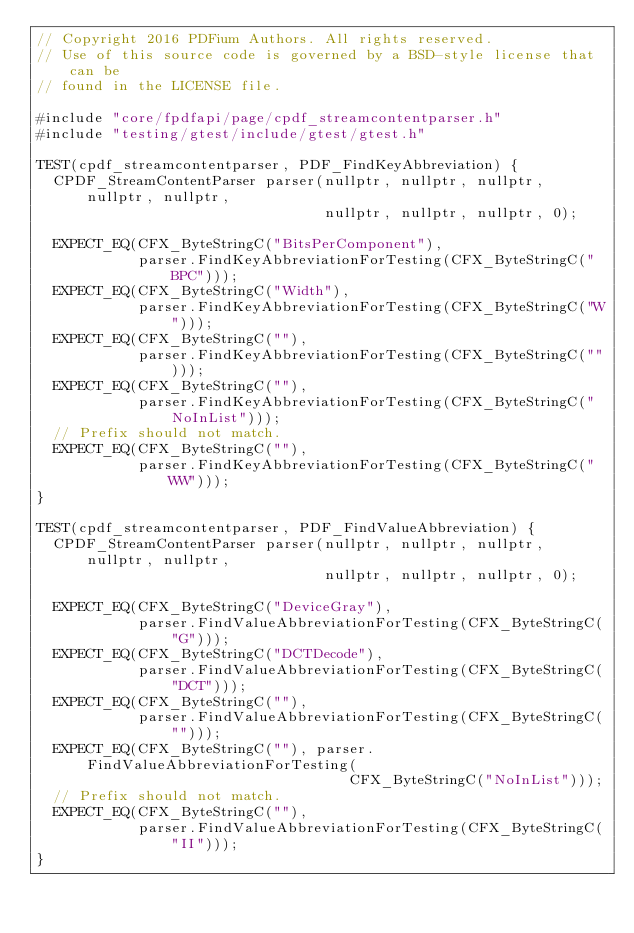Convert code to text. <code><loc_0><loc_0><loc_500><loc_500><_C++_>// Copyright 2016 PDFium Authors. All rights reserved.
// Use of this source code is governed by a BSD-style license that can be
// found in the LICENSE file.

#include "core/fpdfapi/page/cpdf_streamcontentparser.h"
#include "testing/gtest/include/gtest/gtest.h"

TEST(cpdf_streamcontentparser, PDF_FindKeyAbbreviation) {
  CPDF_StreamContentParser parser(nullptr, nullptr, nullptr, nullptr, nullptr,
                                  nullptr, nullptr, nullptr, 0);

  EXPECT_EQ(CFX_ByteStringC("BitsPerComponent"),
            parser.FindKeyAbbreviationForTesting(CFX_ByteStringC("BPC")));
  EXPECT_EQ(CFX_ByteStringC("Width"),
            parser.FindKeyAbbreviationForTesting(CFX_ByteStringC("W")));
  EXPECT_EQ(CFX_ByteStringC(""),
            parser.FindKeyAbbreviationForTesting(CFX_ByteStringC("")));
  EXPECT_EQ(CFX_ByteStringC(""),
            parser.FindKeyAbbreviationForTesting(CFX_ByteStringC("NoInList")));
  // Prefix should not match.
  EXPECT_EQ(CFX_ByteStringC(""),
            parser.FindKeyAbbreviationForTesting(CFX_ByteStringC("WW")));
}

TEST(cpdf_streamcontentparser, PDF_FindValueAbbreviation) {
  CPDF_StreamContentParser parser(nullptr, nullptr, nullptr, nullptr, nullptr,
                                  nullptr, nullptr, nullptr, 0);

  EXPECT_EQ(CFX_ByteStringC("DeviceGray"),
            parser.FindValueAbbreviationForTesting(CFX_ByteStringC("G")));
  EXPECT_EQ(CFX_ByteStringC("DCTDecode"),
            parser.FindValueAbbreviationForTesting(CFX_ByteStringC("DCT")));
  EXPECT_EQ(CFX_ByteStringC(""),
            parser.FindValueAbbreviationForTesting(CFX_ByteStringC("")));
  EXPECT_EQ(CFX_ByteStringC(""), parser.FindValueAbbreviationForTesting(
                                     CFX_ByteStringC("NoInList")));
  // Prefix should not match.
  EXPECT_EQ(CFX_ByteStringC(""),
            parser.FindValueAbbreviationForTesting(CFX_ByteStringC("II")));
}
</code> 